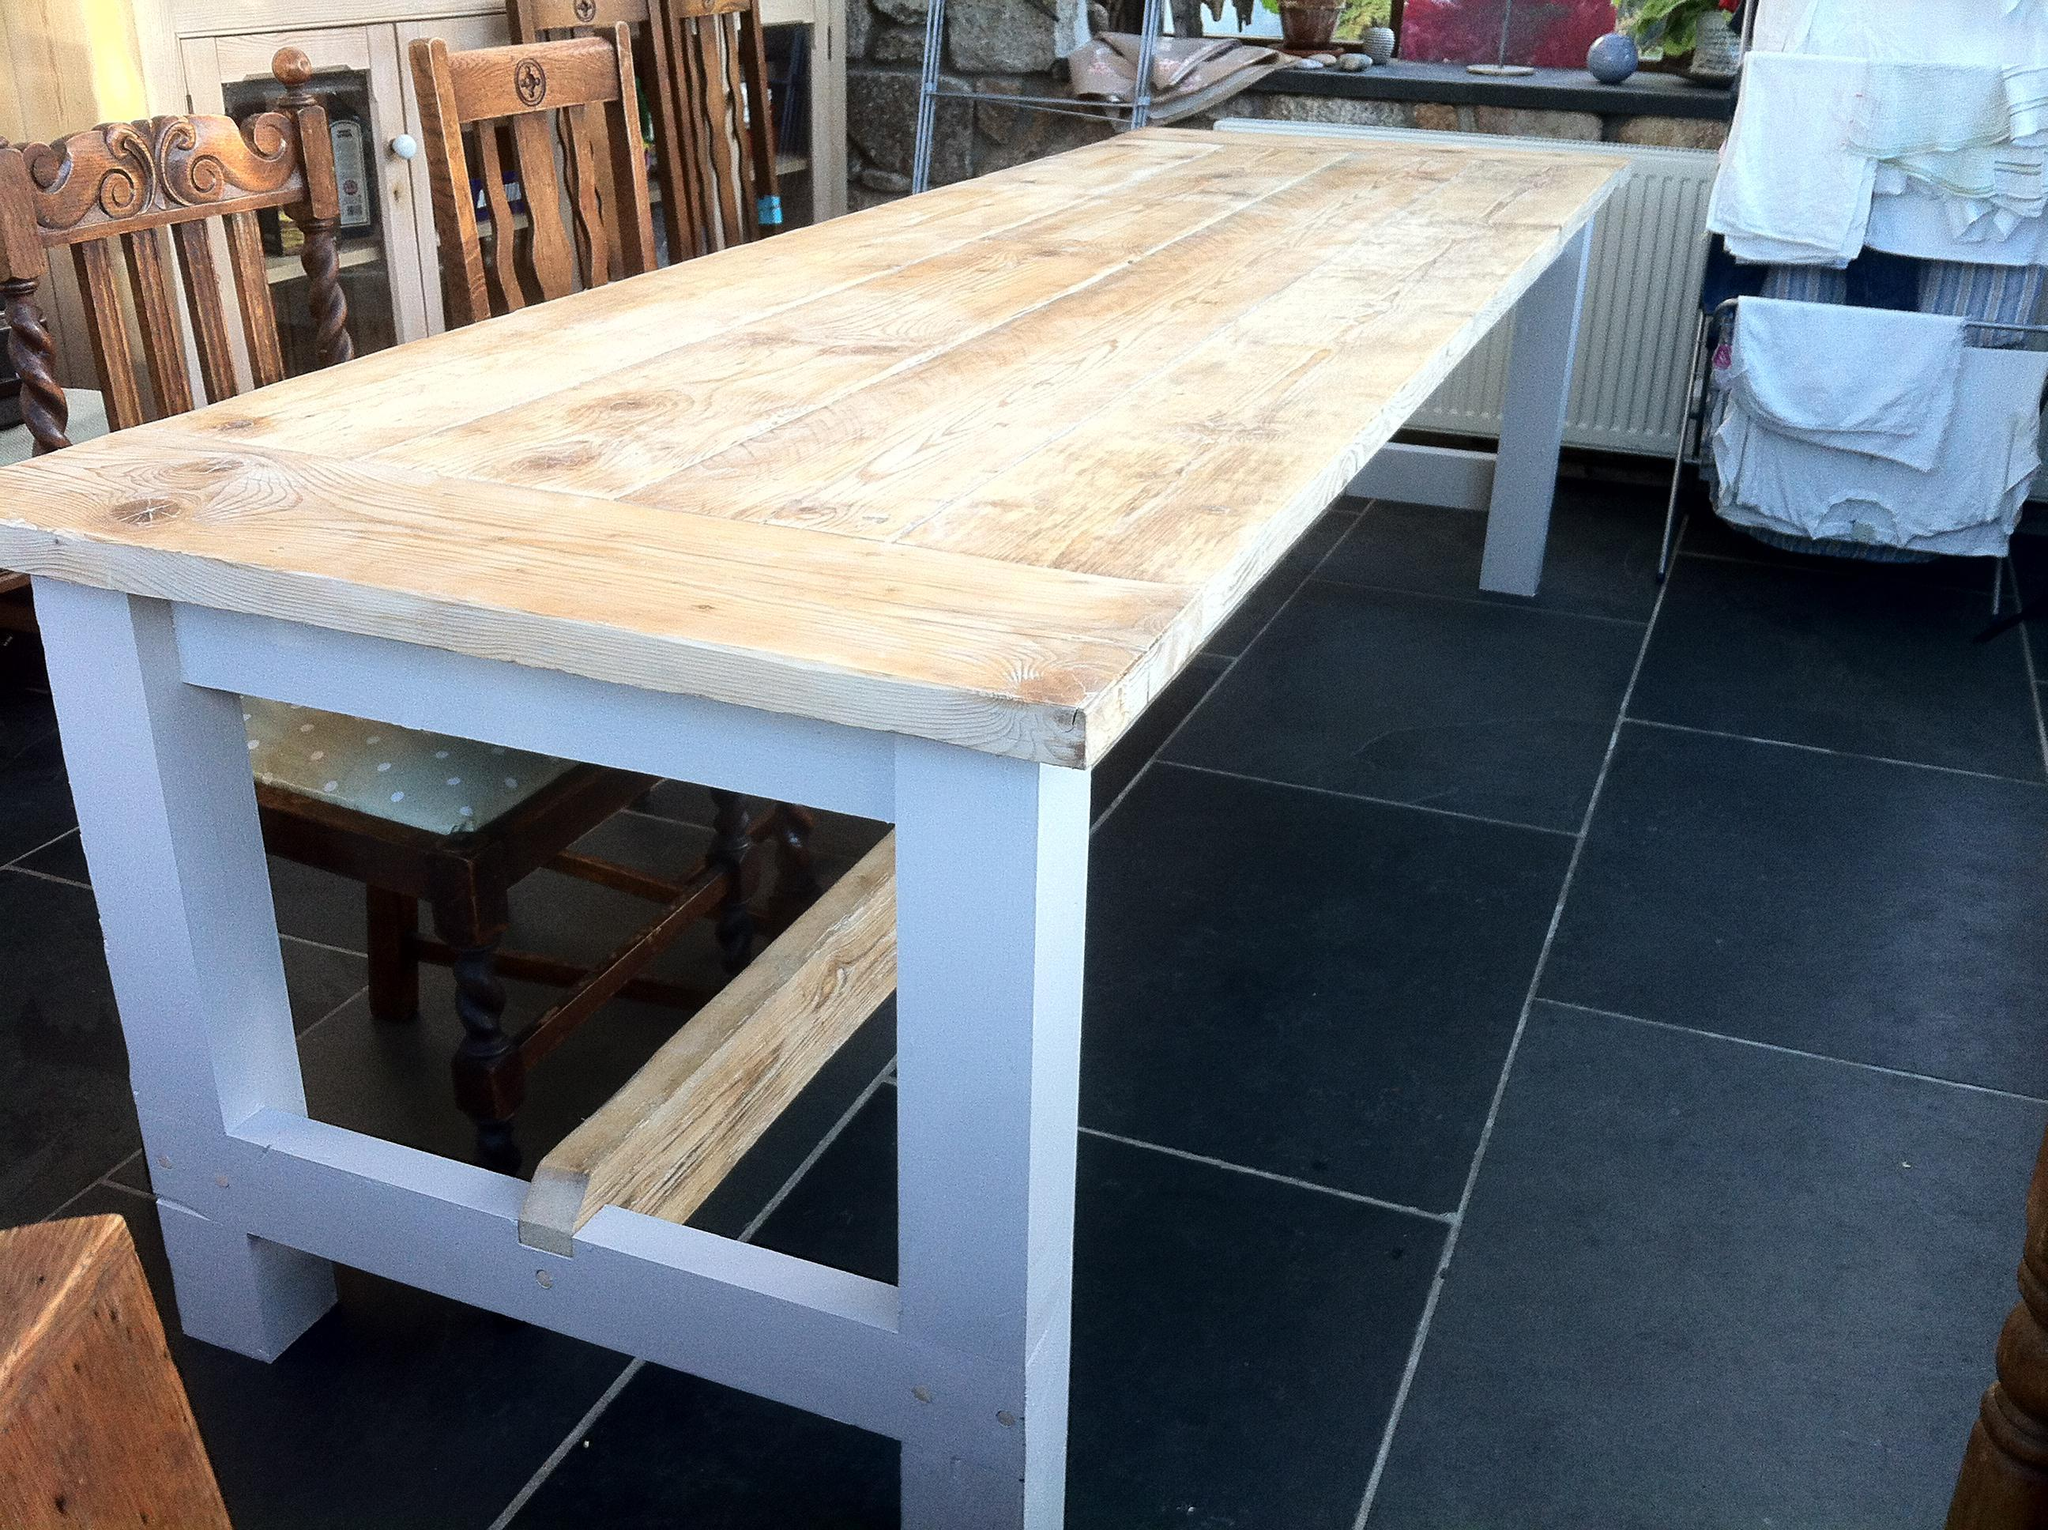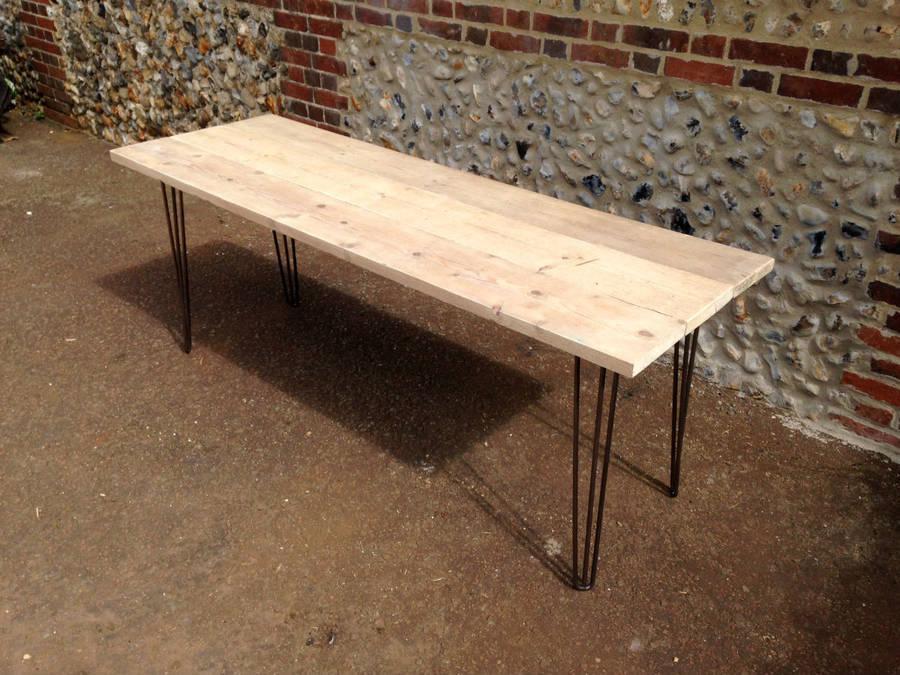The first image is the image on the left, the second image is the image on the right. Evaluate the accuracy of this statement regarding the images: "There is a bench left of the table in one of the images". Is it true? Answer yes or no. No. The first image is the image on the left, the second image is the image on the right. Considering the images on both sides, is "One table has bench seating." valid? Answer yes or no. No. 